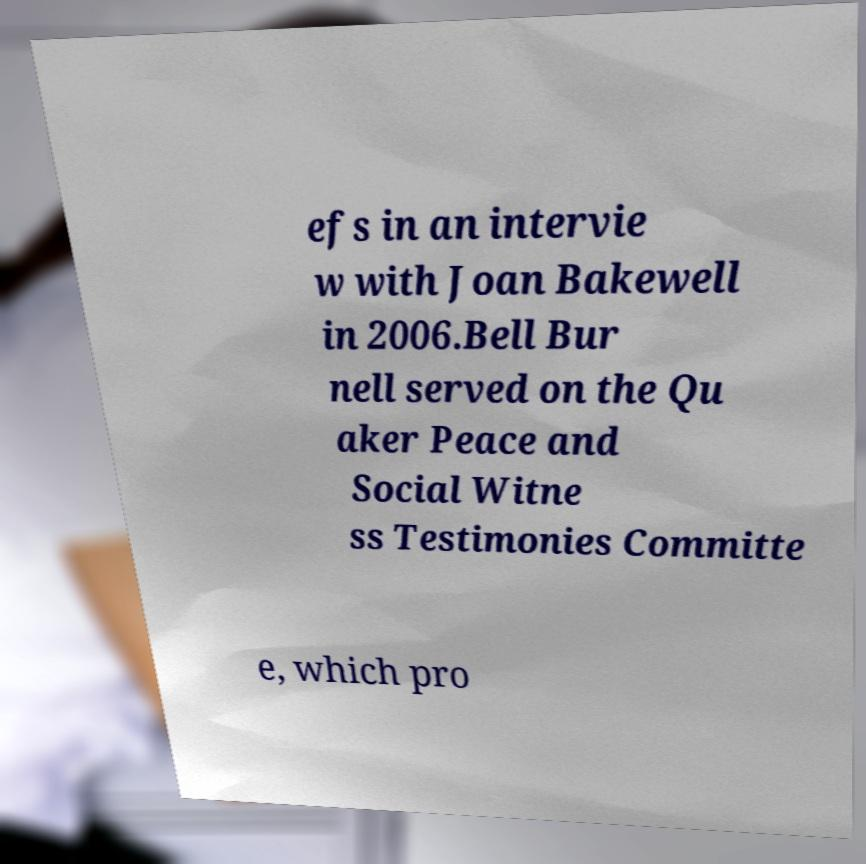Could you extract and type out the text from this image? efs in an intervie w with Joan Bakewell in 2006.Bell Bur nell served on the Qu aker Peace and Social Witne ss Testimonies Committe e, which pro 